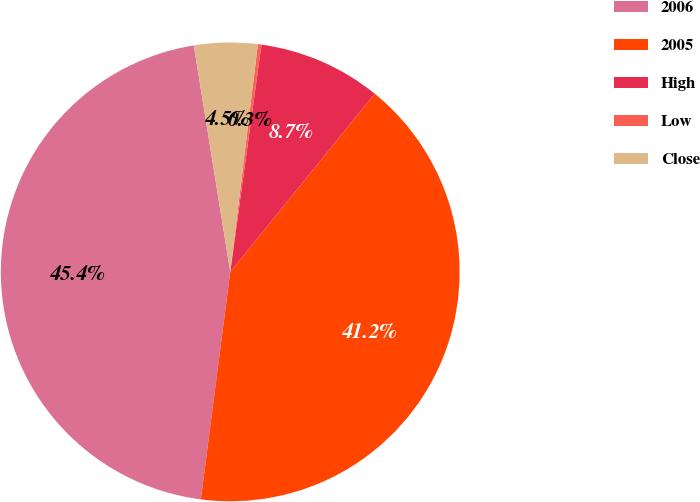Convert chart to OTSL. <chart><loc_0><loc_0><loc_500><loc_500><pie_chart><fcel>2006<fcel>2005<fcel>High<fcel>Low<fcel>Close<nl><fcel>45.41%<fcel>41.2%<fcel>8.67%<fcel>0.25%<fcel>4.46%<nl></chart> 